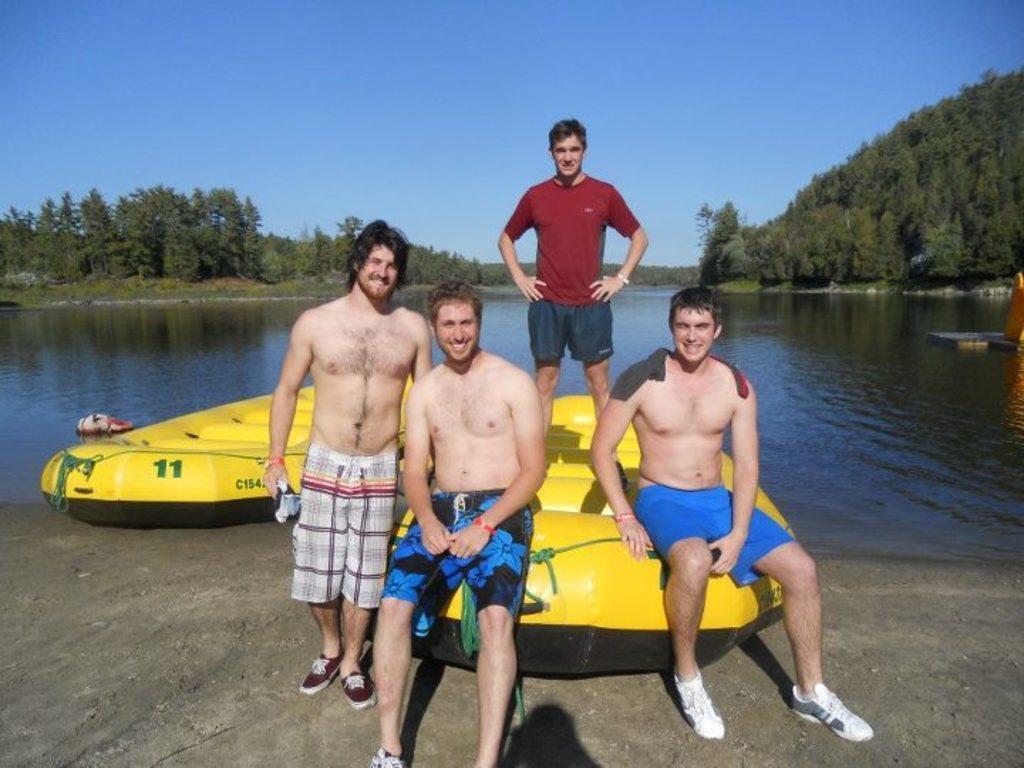Could you give a brief overview of what you see in this image? In this picture we can see four men here, there are two boats here, in the background there are some trees, we can see water at the bottom, there is the sky at the top of the picture. 